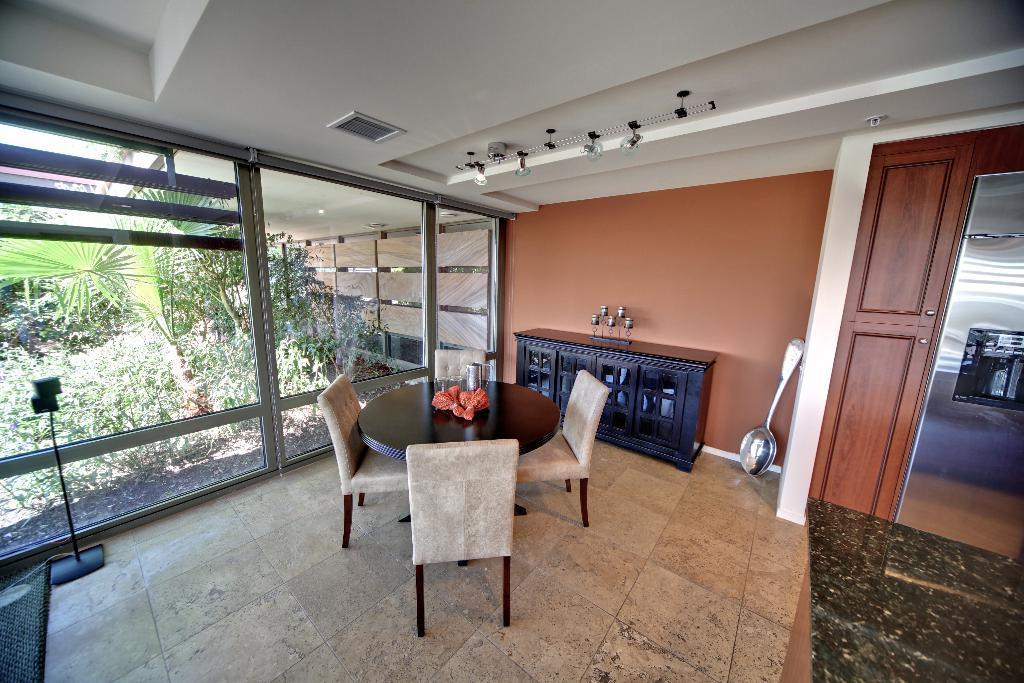How would you summarize this image in a sentence or two? In this picture we can see a table, chairs, jar, cupboards, some objects on the floor and in the background we can see a wall, roof, lights, glass, from glass we can see trees. 